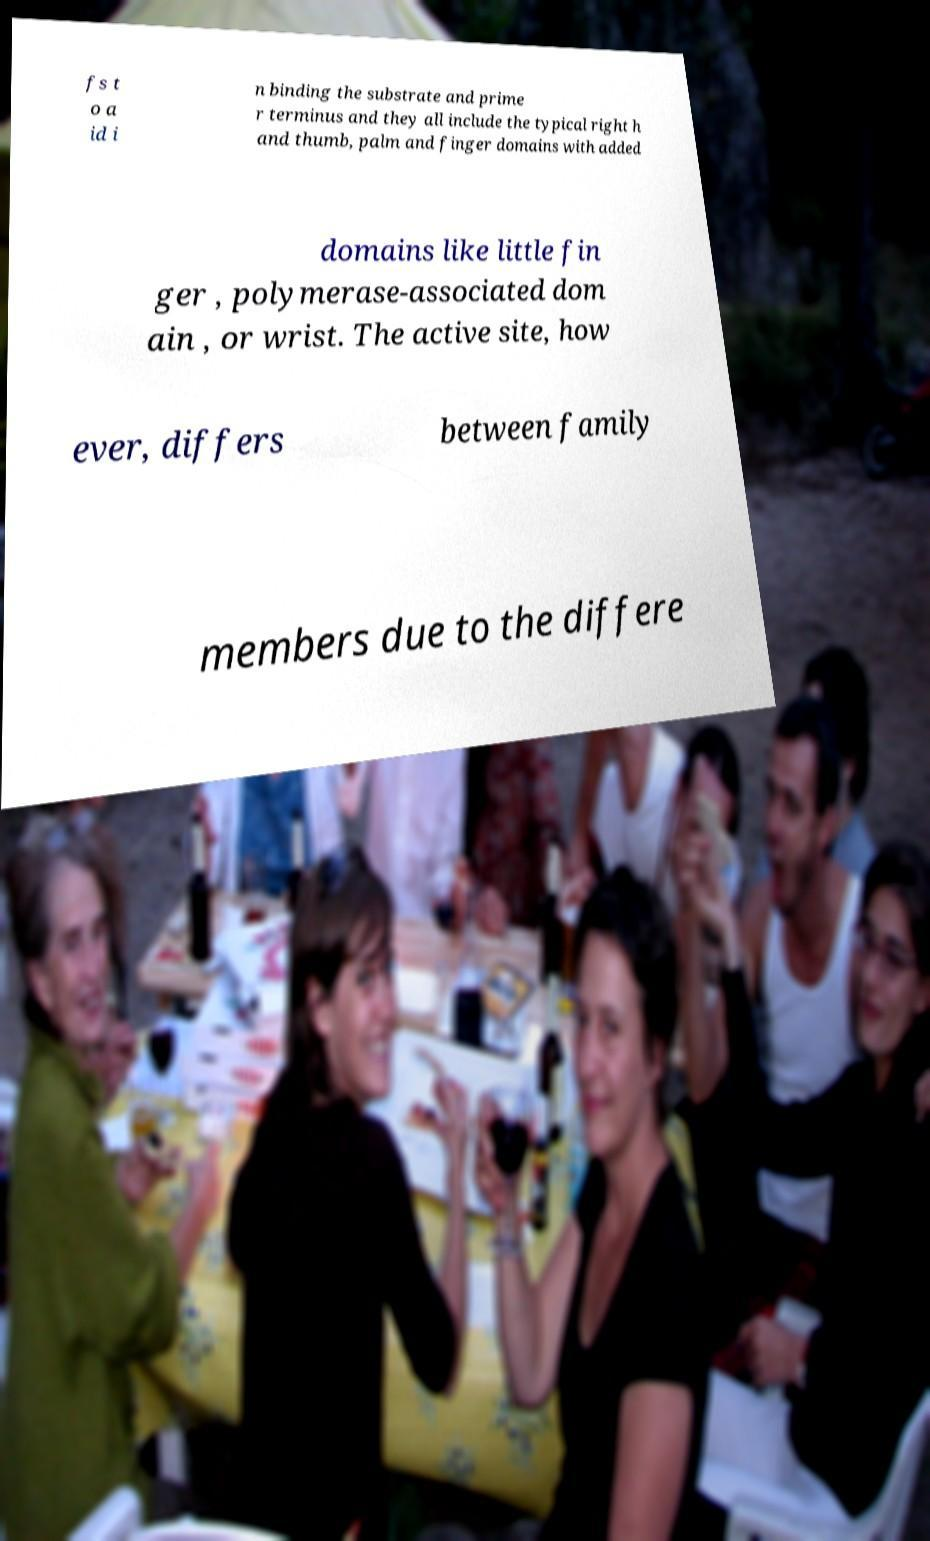For documentation purposes, I need the text within this image transcribed. Could you provide that? fs t o a id i n binding the substrate and prime r terminus and they all include the typical right h and thumb, palm and finger domains with added domains like little fin ger , polymerase-associated dom ain , or wrist. The active site, how ever, differs between family members due to the differe 